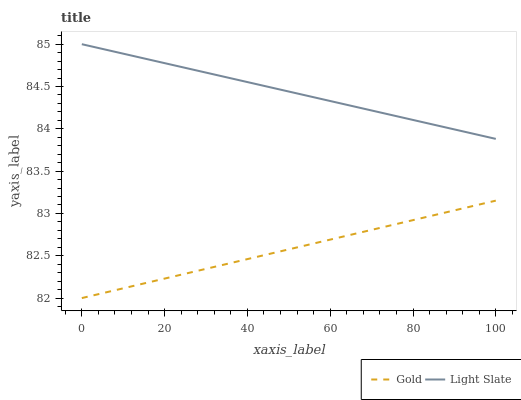Does Gold have the minimum area under the curve?
Answer yes or no. Yes. Does Light Slate have the maximum area under the curve?
Answer yes or no. Yes. Does Gold have the maximum area under the curve?
Answer yes or no. No. Is Gold the smoothest?
Answer yes or no. Yes. Is Light Slate the roughest?
Answer yes or no. Yes. Is Gold the roughest?
Answer yes or no. No. Does Gold have the lowest value?
Answer yes or no. Yes. Does Light Slate have the highest value?
Answer yes or no. Yes. Does Gold have the highest value?
Answer yes or no. No. Is Gold less than Light Slate?
Answer yes or no. Yes. Is Light Slate greater than Gold?
Answer yes or no. Yes. Does Gold intersect Light Slate?
Answer yes or no. No. 